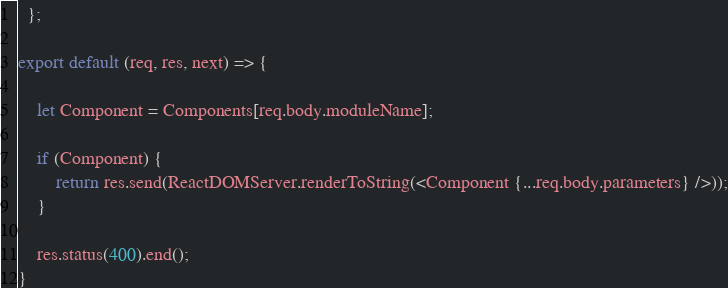Convert code to text. <code><loc_0><loc_0><loc_500><loc_500><_JavaScript_>  };

export default (req, res, next) => {

    let Component = Components[req.body.moduleName];
	
	if (Component) {
		return res.send(ReactDOMServer.renderToString(<Component {...req.body.parameters} />));
	}
	
	res.status(400).end();
}</code> 